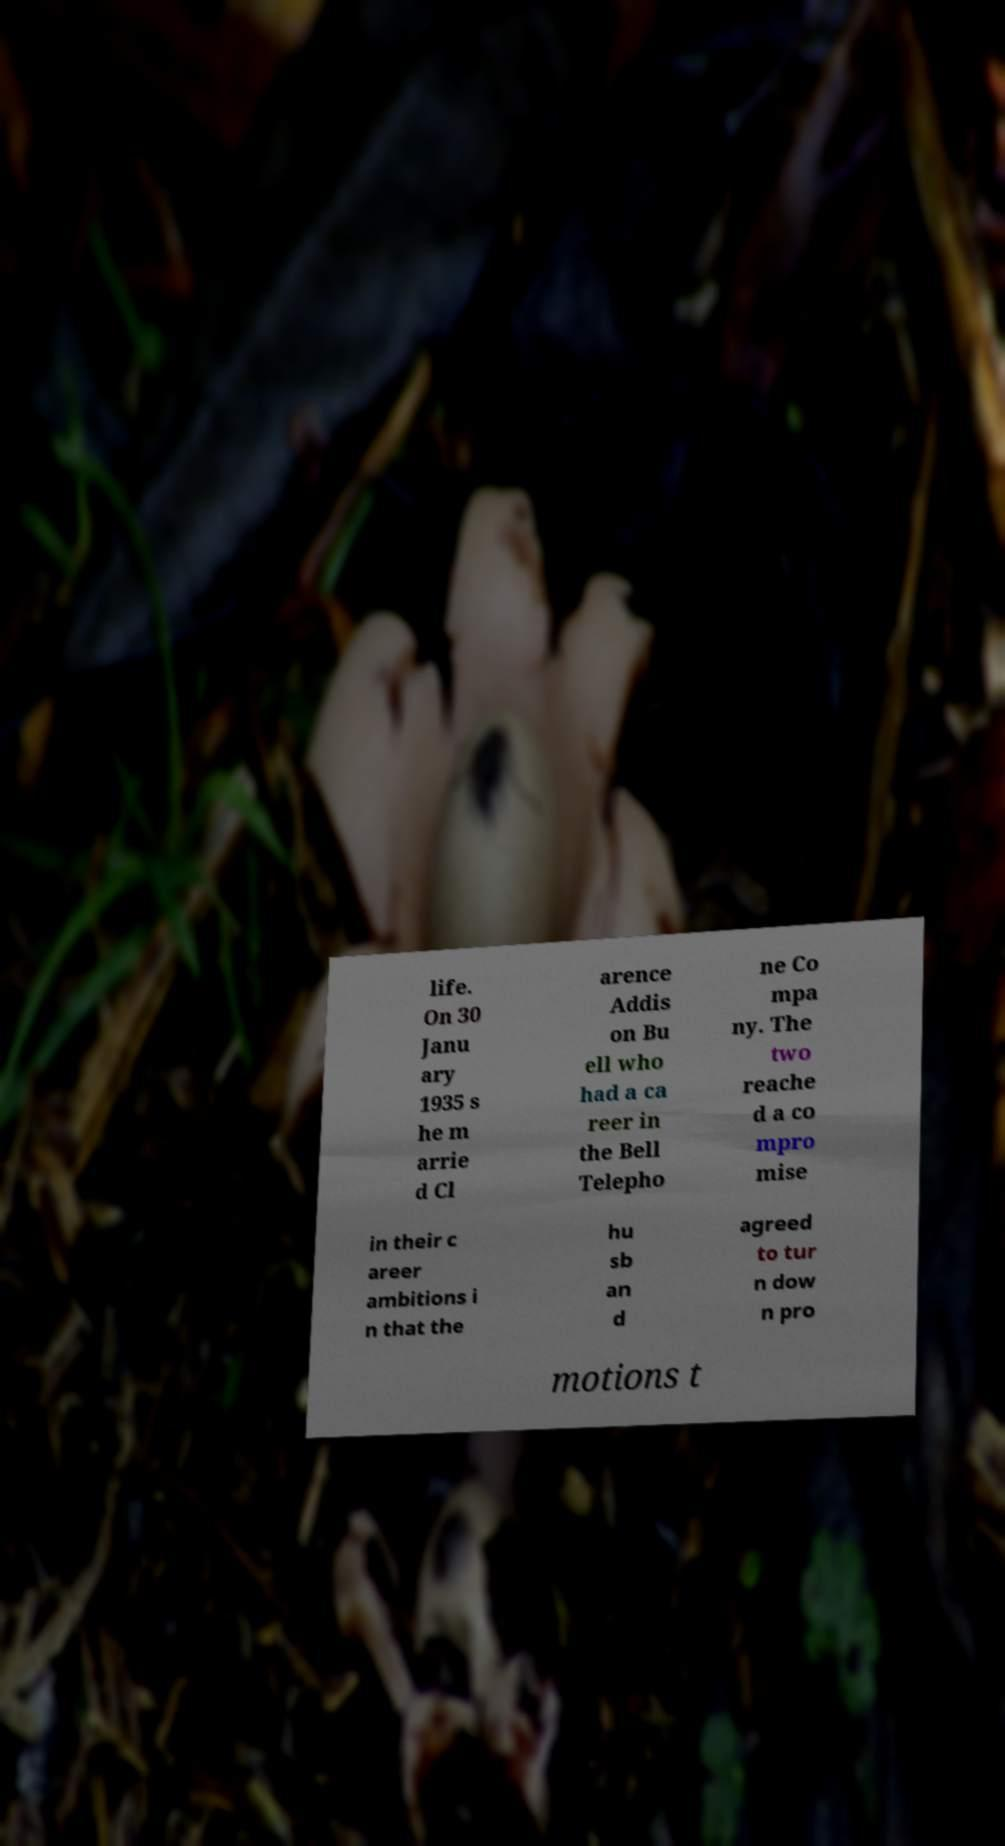There's text embedded in this image that I need extracted. Can you transcribe it verbatim? life. On 30 Janu ary 1935 s he m arrie d Cl arence Addis on Bu ell who had a ca reer in the Bell Telepho ne Co mpa ny. The two reache d a co mpro mise in their c areer ambitions i n that the hu sb an d agreed to tur n dow n pro motions t 